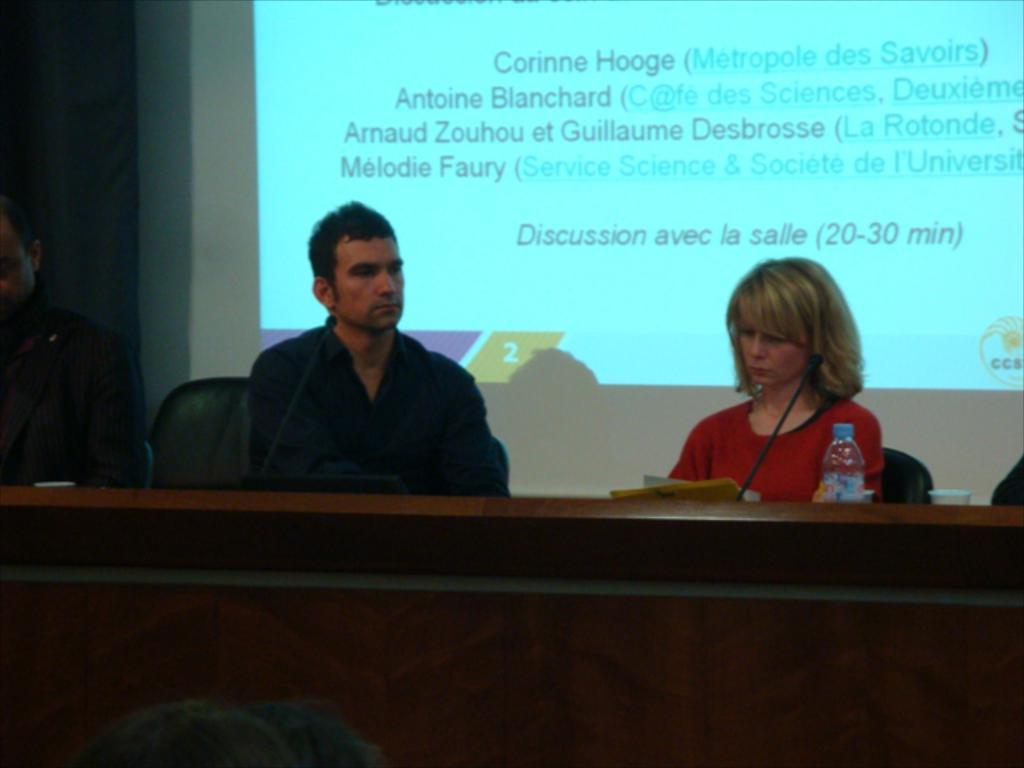What type of structure can be seen in the image? There is a wall in the image. What is the main object on the wall? There is a screen on the wall. What piece of furniture is present in the image? There is a table in the image. What device is visible on the table? There is a mic on the table. How many people are sitting in the image? There are three persons sitting on chairs. What items can be seen on the table besides the mic? There is a bottle and a glass on the table. What is the distance between the furniture and the waste in the image? There is no mention of furniture or waste in the image, so it is not possible to determine the distance between them. 